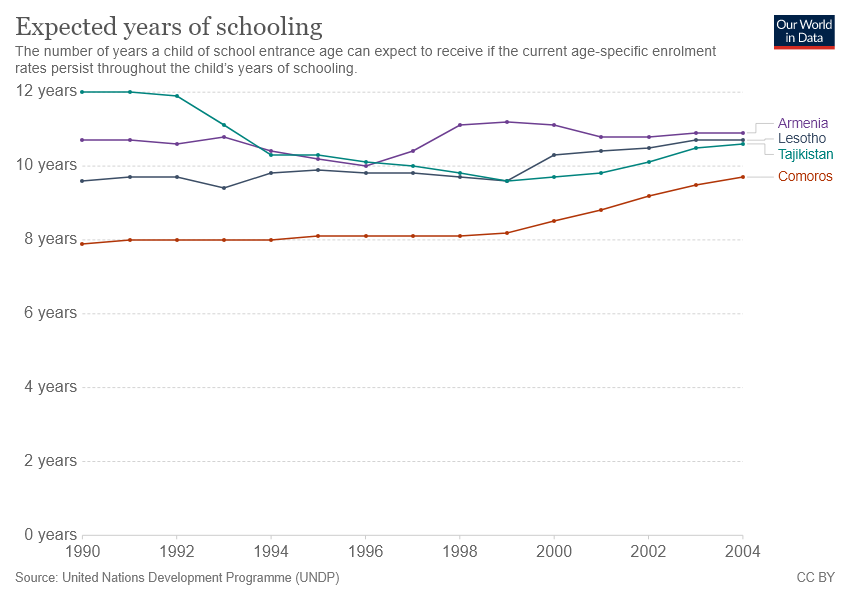Outline some significant characteristics in this image. The expected years of schooling were highest in Armenia in the year 1990. Tajikistan has a higher expected years of schooling than Comoros. 